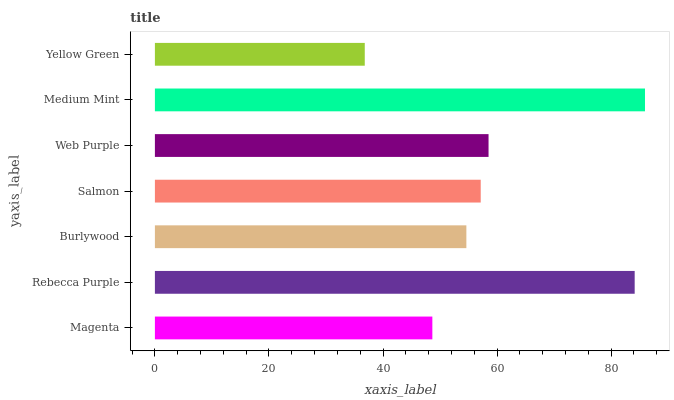Is Yellow Green the minimum?
Answer yes or no. Yes. Is Medium Mint the maximum?
Answer yes or no. Yes. Is Rebecca Purple the minimum?
Answer yes or no. No. Is Rebecca Purple the maximum?
Answer yes or no. No. Is Rebecca Purple greater than Magenta?
Answer yes or no. Yes. Is Magenta less than Rebecca Purple?
Answer yes or no. Yes. Is Magenta greater than Rebecca Purple?
Answer yes or no. No. Is Rebecca Purple less than Magenta?
Answer yes or no. No. Is Salmon the high median?
Answer yes or no. Yes. Is Salmon the low median?
Answer yes or no. Yes. Is Yellow Green the high median?
Answer yes or no. No. Is Web Purple the low median?
Answer yes or no. No. 